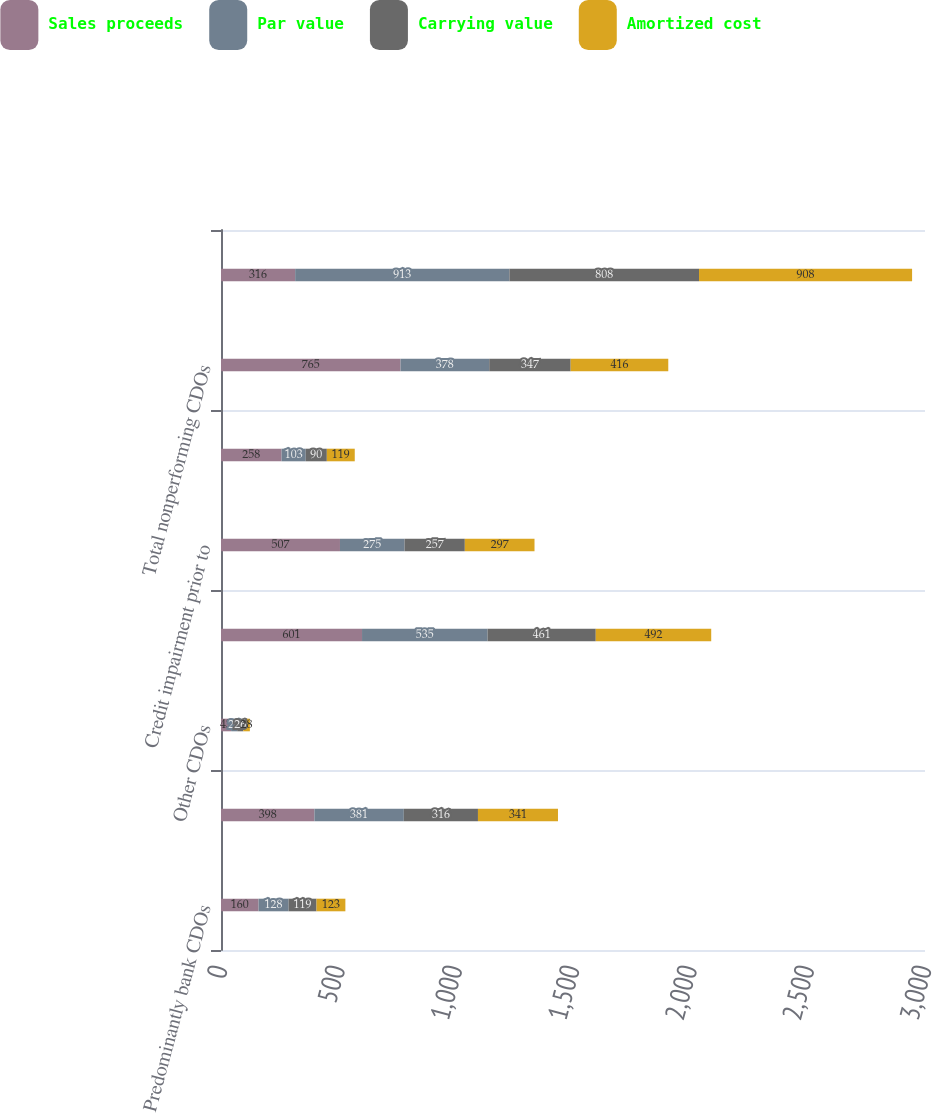Convert chart. <chart><loc_0><loc_0><loc_500><loc_500><stacked_bar_chart><ecel><fcel>Predominantly bank CDOs<fcel>Insurance CDOs<fcel>Other CDOs<fcel>Total performing CDOs<fcel>Credit impairment prior to<fcel>Credit impairment during last<fcel>Total nonperforming CDOs<fcel>Total<nl><fcel>Sales proceeds<fcel>160<fcel>398<fcel>43<fcel>601<fcel>507<fcel>258<fcel>765<fcel>316<nl><fcel>Par value<fcel>128<fcel>381<fcel>26<fcel>535<fcel>275<fcel>103<fcel>378<fcel>913<nl><fcel>Carrying value<fcel>119<fcel>316<fcel>26<fcel>461<fcel>257<fcel>90<fcel>347<fcel>808<nl><fcel>Amortized cost<fcel>123<fcel>341<fcel>28<fcel>492<fcel>297<fcel>119<fcel>416<fcel>908<nl></chart> 